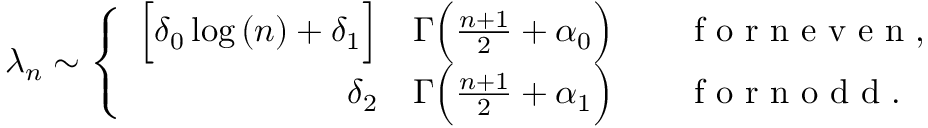<formula> <loc_0><loc_0><loc_500><loc_500>\lambda _ { n } \sim \left \{ \begin{array} { r l } { \left [ \delta _ { 0 } \log { ( n ) } + \delta _ { 1 } \right ] } & \Gamma \left ( \frac { n + 1 } { 2 } + \alpha _ { 0 } \right ) \quad f o r n e v e n , } \\ { \delta _ { 2 } } & \Gamma \left ( \frac { n + 1 } { 2 } + \alpha _ { 1 } \right ) \quad f o r n o d d . } \end{array}</formula> 